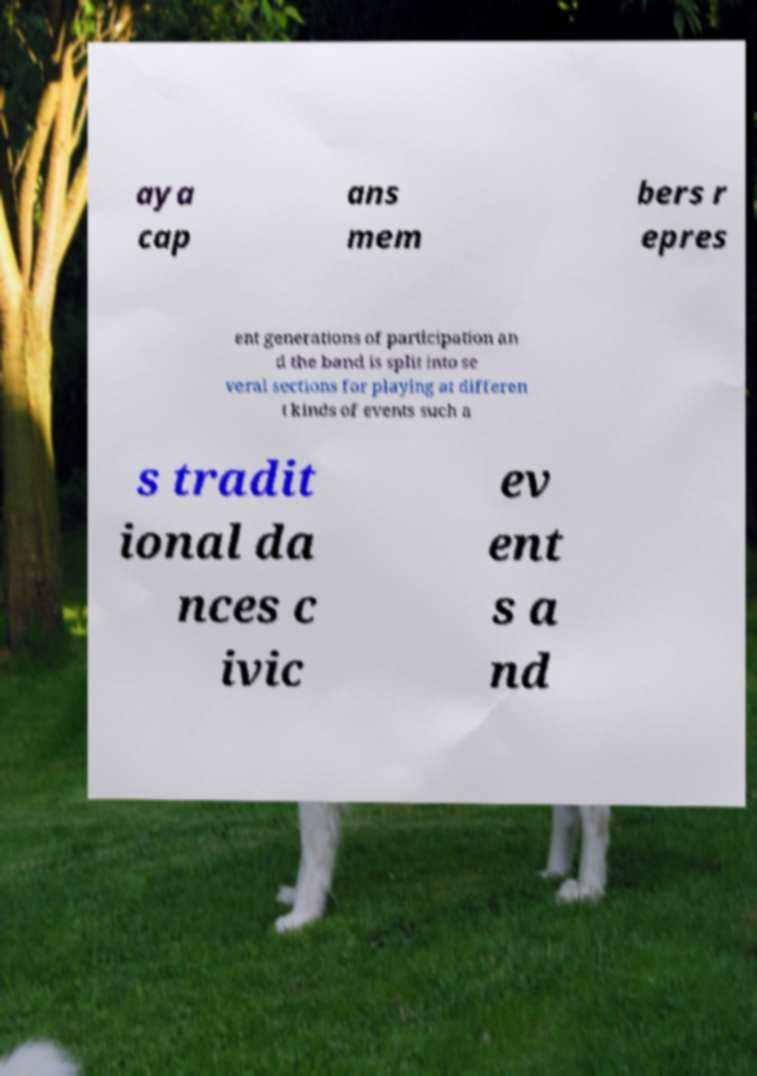Could you assist in decoding the text presented in this image and type it out clearly? aya cap ans mem bers r epres ent generations of participation an d the band is split into se veral sections for playing at differen t kinds of events such a s tradit ional da nces c ivic ev ent s a nd 